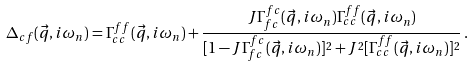Convert formula to latex. <formula><loc_0><loc_0><loc_500><loc_500>\Delta _ { c f } ( \vec { q } , i \omega _ { n } ) = \Gamma ^ { f f } _ { c c } ( \vec { q } , i \omega _ { n } ) + \frac { J \Gamma ^ { f c } _ { f c } ( \vec { q } , i \omega _ { n } ) \Gamma ^ { f f } _ { c c } ( \vec { q } , i \omega _ { n } ) } { [ 1 - J \Gamma ^ { f c } _ { f c } ( \vec { q } , i \omega _ { n } ) ] ^ { 2 } + J ^ { 2 } [ \Gamma ^ { f f } _ { c c } ( \vec { q } , i \omega _ { n } ) ] ^ { 2 } } \, .</formula> 